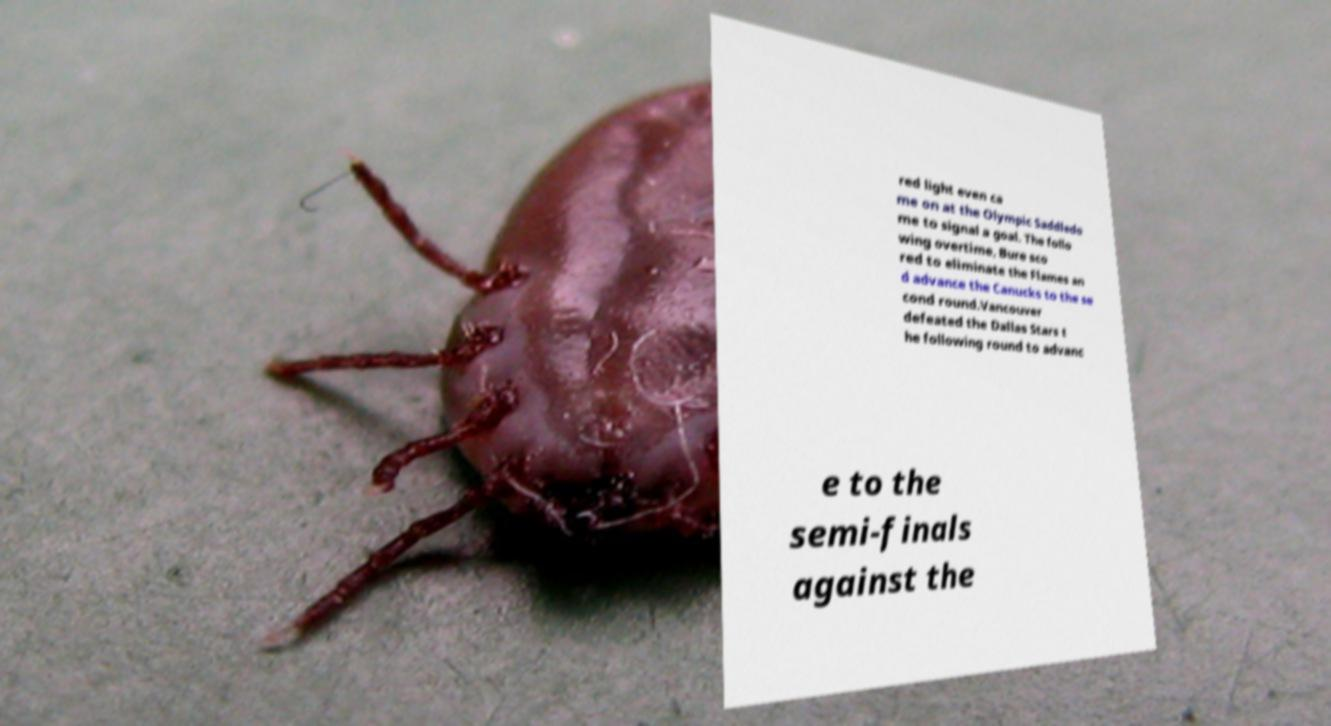I need the written content from this picture converted into text. Can you do that? red light even ca me on at the Olympic Saddledo me to signal a goal. The follo wing overtime, Bure sco red to eliminate the Flames an d advance the Canucks to the se cond round.Vancouver defeated the Dallas Stars t he following round to advanc e to the semi-finals against the 